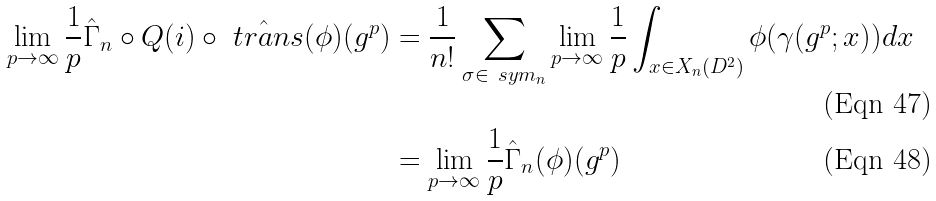<formula> <loc_0><loc_0><loc_500><loc_500>\lim _ { p \to \infty } \frac { 1 } { p } \hat { \Gamma } _ { n } \circ Q ( i ) \circ \hat { \ t r a n s } ( \phi ) ( g ^ { p } ) & = \frac { 1 } { n ! } \sum _ { \sigma \in \ s y m _ { n } } \lim _ { p \to \infty } \frac { 1 } { p } \int _ { x \in X _ { n } ( D ^ { 2 } ) } \phi ( \gamma ( g ^ { p } ; x ) ) d x \\ & = \lim _ { p \to \infty } \frac { 1 } { p } \hat { \Gamma } _ { n } ( \phi ) ( g ^ { p } )</formula> 